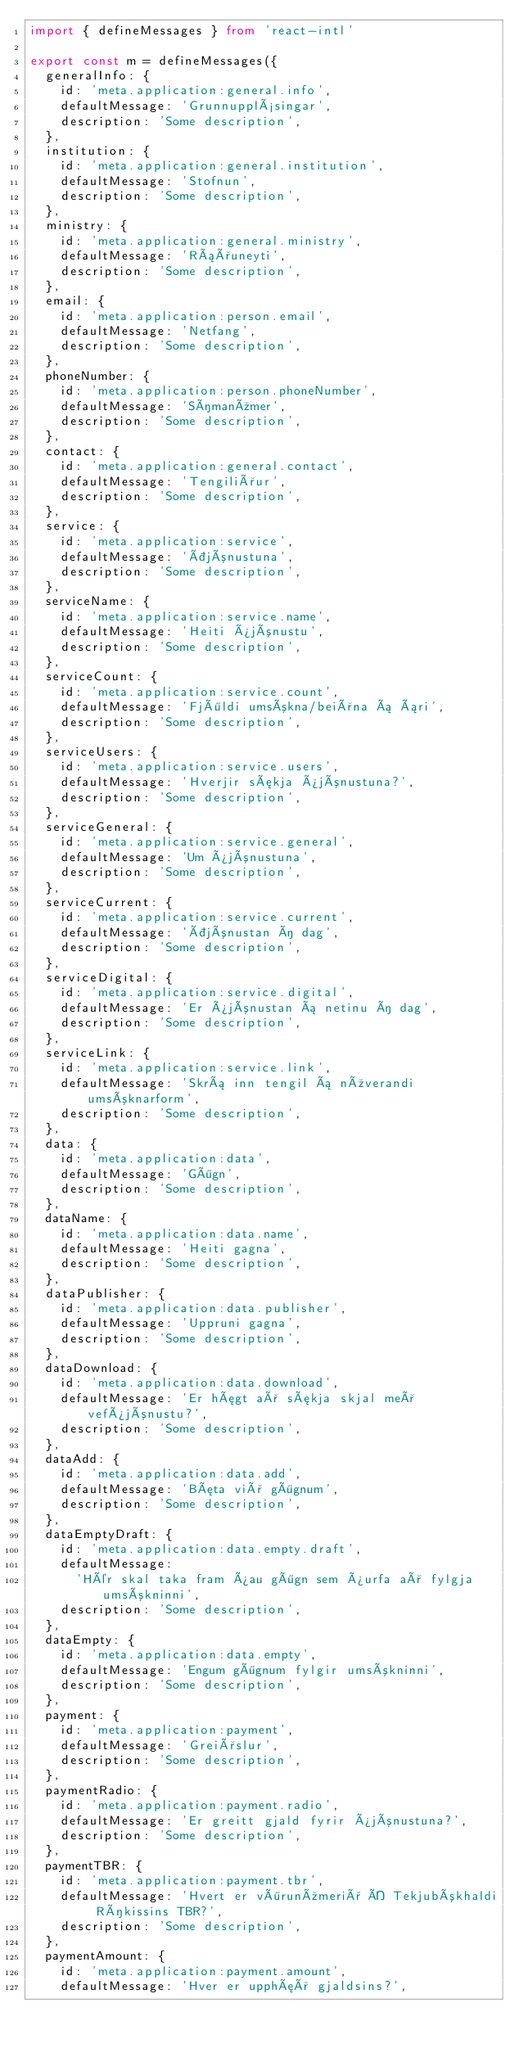Convert code to text. <code><loc_0><loc_0><loc_500><loc_500><_TypeScript_>import { defineMessages } from 'react-intl'

export const m = defineMessages({
  generalInfo: {
    id: 'meta.application:general.info',
    defaultMessage: 'Grunnupplýsingar',
    description: 'Some description',
  },
  institution: {
    id: 'meta.application:general.institution',
    defaultMessage: 'Stofnun',
    description: 'Some description',
  },
  ministry: {
    id: 'meta.application:general.ministry',
    defaultMessage: 'Ráðuneyti',
    description: 'Some description',
  },
  email: {
    id: 'meta.application:person.email',
    defaultMessage: 'Netfang',
    description: 'Some description',
  },
  phoneNumber: {
    id: 'meta.application:person.phoneNumber',
    defaultMessage: 'Símanúmer',
    description: 'Some description',
  },
  contact: {
    id: 'meta.application:general.contact',
    defaultMessage: 'Tengiliður',
    description: 'Some description',
  },
  service: {
    id: 'meta.application:service',
    defaultMessage: 'Þjónustuna',
    description: 'Some description',
  },
  serviceName: {
    id: 'meta.application:service.name',
    defaultMessage: 'Heiti þjónustu',
    description: 'Some description',
  },
  serviceCount: {
    id: 'meta.application:service.count',
    defaultMessage: 'Fjöldi umsókna/beiðna á ári',
    description: 'Some description',
  },
  serviceUsers: {
    id: 'meta.application:service.users',
    defaultMessage: 'Hverjir sækja þjónustuna?',
    description: 'Some description',
  },
  serviceGeneral: {
    id: 'meta.application:service.general',
    defaultMessage: 'Um þjónustuna',
    description: 'Some description',
  },
  serviceCurrent: {
    id: 'meta.application:service.current',
    defaultMessage: 'Þjónustan í dag',
    description: 'Some description',
  },
  serviceDigital: {
    id: 'meta.application:service.digital',
    defaultMessage: 'Er þjónustan á netinu í dag',
    description: 'Some description',
  },
  serviceLink: {
    id: 'meta.application:service.link',
    defaultMessage: 'Skrá inn tengil á núverandi umsóknarform',
    description: 'Some description',
  },
  data: {
    id: 'meta.application:data',
    defaultMessage: 'Gögn',
    description: 'Some description',
  },
  dataName: {
    id: 'meta.application:data.name',
    defaultMessage: 'Heiti gagna',
    description: 'Some description',
  },
  dataPublisher: {
    id: 'meta.application:data.publisher',
    defaultMessage: 'Uppruni gagna',
    description: 'Some description',
  },
  dataDownload: {
    id: 'meta.application:data.download',
    defaultMessage: 'Er hægt að sækja skjal með vefþjónustu?',
    description: 'Some description',
  },
  dataAdd: {
    id: 'meta.application:data.add',
    defaultMessage: 'Bæta við gögnum',
    description: 'Some description',
  },
  dataEmptyDraft: {
    id: 'meta.application:data.empty.draft',
    defaultMessage:
      'Hér skal taka fram þau gögn sem þurfa að fylgja umsókninni',
    description: 'Some description',
  },
  dataEmpty: {
    id: 'meta.application:data.empty',
    defaultMessage: 'Engum gögnum fylgir umsókninni',
    description: 'Some description',
  },
  payment: {
    id: 'meta.application:payment',
    defaultMessage: 'Greiðslur',
    description: 'Some description',
  },
  paymentRadio: {
    id: 'meta.application:payment.radio',
    defaultMessage: 'Er greitt gjald fyrir þjónustuna?',
    description: 'Some description',
  },
  paymentTBR: {
    id: 'meta.application:payment.tbr',
    defaultMessage: 'Hvert er vörunúmerið Í Tekjubókhaldi Ríkissins TBR?',
    description: 'Some description',
  },
  paymentAmount: {
    id: 'meta.application:payment.amount',
    defaultMessage: 'Hver er upphæð gjaldsins?',</code> 